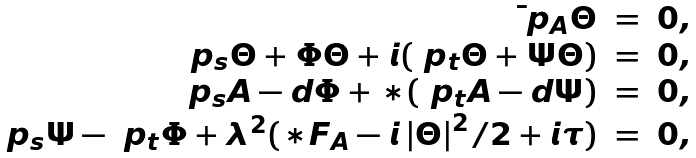<formula> <loc_0><loc_0><loc_500><loc_500>\begin{array} { r c l } \bar { \ } p _ { A } \Theta & = & 0 , \\ \ p _ { s } \Theta + \Phi \Theta + i ( \ p _ { t } \Theta + \Psi \Theta ) & = & 0 , \\ \ p _ { s } A - d \Phi + * ( \ p _ { t } A - d \Psi ) & = & 0 , \\ \ p _ { s } \Psi - \ p _ { t } \Phi + \lambda ^ { 2 } ( * F _ { A } - i \left | \Theta \right | ^ { 2 } / 2 + i \tau ) & = & 0 , \end{array}</formula> 